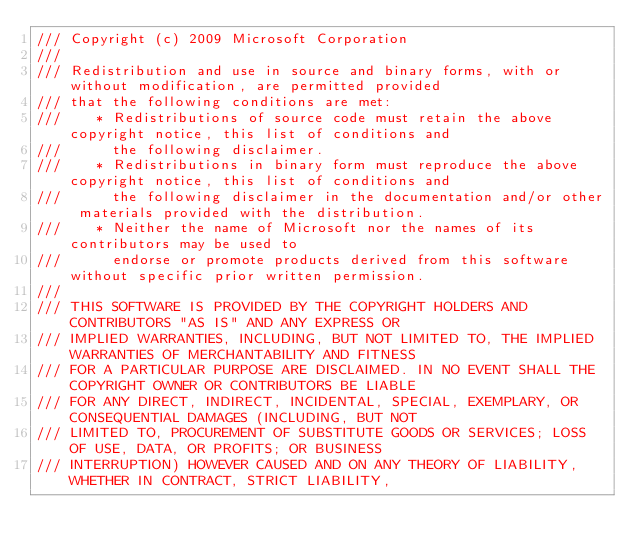<code> <loc_0><loc_0><loc_500><loc_500><_JavaScript_>/// Copyright (c) 2009 Microsoft Corporation 
/// 
/// Redistribution and use in source and binary forms, with or without modification, are permitted provided
/// that the following conditions are met: 
///    * Redistributions of source code must retain the above copyright notice, this list of conditions and
///      the following disclaimer. 
///    * Redistributions in binary form must reproduce the above copyright notice, this list of conditions and 
///      the following disclaimer in the documentation and/or other materials provided with the distribution.  
///    * Neither the name of Microsoft nor the names of its contributors may be used to
///      endorse or promote products derived from this software without specific prior written permission.
/// 
/// THIS SOFTWARE IS PROVIDED BY THE COPYRIGHT HOLDERS AND CONTRIBUTORS "AS IS" AND ANY EXPRESS OR
/// IMPLIED WARRANTIES, INCLUDING, BUT NOT LIMITED TO, THE IMPLIED WARRANTIES OF MERCHANTABILITY AND FITNESS
/// FOR A PARTICULAR PURPOSE ARE DISCLAIMED. IN NO EVENT SHALL THE COPYRIGHT OWNER OR CONTRIBUTORS BE LIABLE
/// FOR ANY DIRECT, INDIRECT, INCIDENTAL, SPECIAL, EXEMPLARY, OR CONSEQUENTIAL DAMAGES (INCLUDING, BUT NOT
/// LIMITED TO, PROCUREMENT OF SUBSTITUTE GOODS OR SERVICES; LOSS OF USE, DATA, OR PROFITS; OR BUSINESS
/// INTERRUPTION) HOWEVER CAUSED AND ON ANY THEORY OF LIABILITY, WHETHER IN CONTRACT, STRICT LIABILITY,</code> 